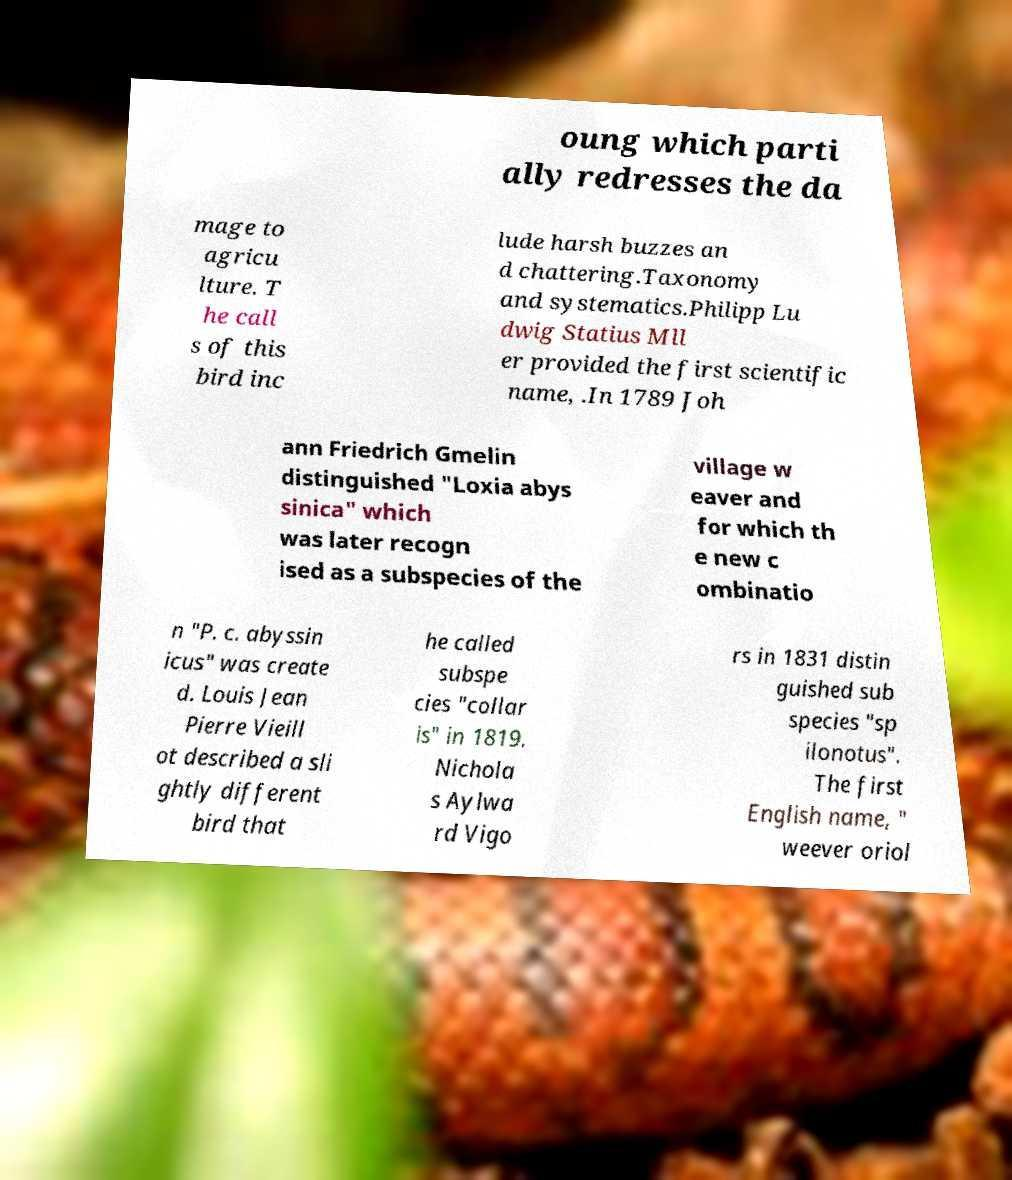Please identify and transcribe the text found in this image. oung which parti ally redresses the da mage to agricu lture. T he call s of this bird inc lude harsh buzzes an d chattering.Taxonomy and systematics.Philipp Lu dwig Statius Mll er provided the first scientific name, .In 1789 Joh ann Friedrich Gmelin distinguished "Loxia abys sinica" which was later recogn ised as a subspecies of the village w eaver and for which th e new c ombinatio n "P. c. abyssin icus" was create d. Louis Jean Pierre Vieill ot described a sli ghtly different bird that he called subspe cies "collar is" in 1819. Nichola s Aylwa rd Vigo rs in 1831 distin guished sub species "sp ilonotus". The first English name, " weever oriol 